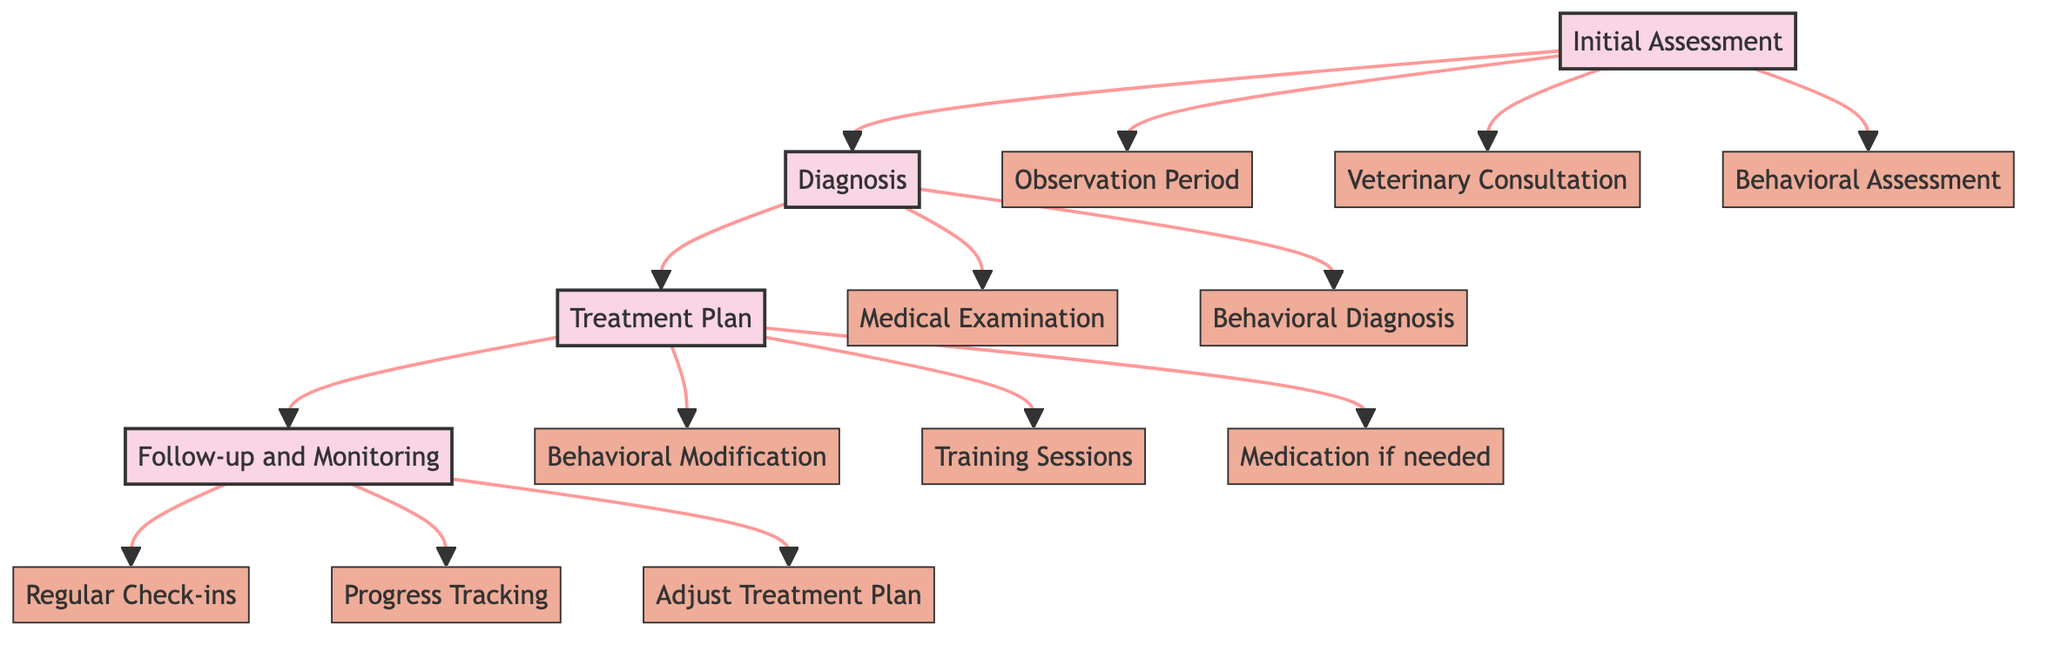What are the four main stages in the clinical pathway? The diagram has four main stages labeled: Initial Assessment, Diagnosis, Treatment Plan, and Follow-up and Monitoring.
Answer: Initial Assessment, Diagnosis, Treatment Plan, Follow-up and Monitoring How many steps are there in the Treatment Plan stage? In the Treatment Plan stage, there are three steps: Behavioral Modification, Training Sessions, and Medication if needed.
Answer: 3 What is the first step in the Initial Assessment stage? The first step listed in the Initial Assessment stage is Observation Period.
Answer: Observation Period Which stage follows Diagnosis in the clinical pathway? After the Diagnosis stage, the next stage shown is Treatment Plan.
Answer: Treatment Plan What type of resources are included for the Behavioral Modification step? The resources listed for Behavioral Modification include Positive Reinforcement Techniques and Interactive Toys.
Answer: Positive Reinforcement Techniques, Interactive Toys What is required to identify specific behavioral disorders? Identifying specific behavioral disorders requires Behavioral Diagnosis, which uses Clinical Behavior Analysis Tools as resources.
Answer: Behavioral Diagnosis Describe the overall purpose of the Follow-up and Monitoring stage. The Follow-up and Monitoring stage aims to check on the pet's progress, adjust treatment if necessary, and ensure ongoing support. It includes Regular Check-ins, Progress Tracking, and Adjust Treatment Plan steps.
Answer: Check on progress and adjust treatment How many total steps are presented in the Diagnosis stage? The Diagnosis stage includes two steps: Medical Examination and Behavioral Diagnosis, making a total of two steps.
Answer: 2 What happens during the Observation Period step? During the Observation Period step, the pet's behavior is monitored for two weeks, utilizing a Behavior Journal and a Pet Camera as primary resources.
Answer: Monitor pet behavior for 2 weeks 